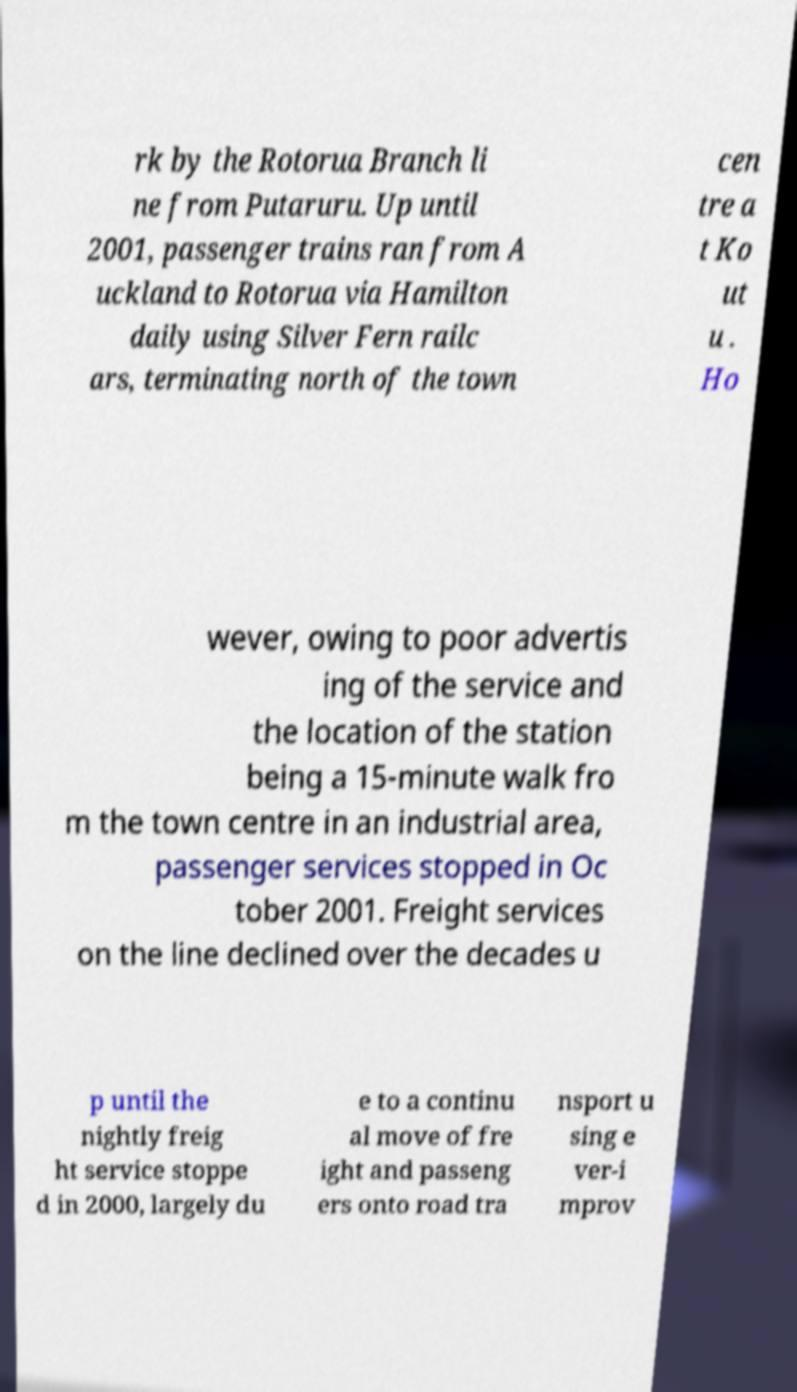For documentation purposes, I need the text within this image transcribed. Could you provide that? rk by the Rotorua Branch li ne from Putaruru. Up until 2001, passenger trains ran from A uckland to Rotorua via Hamilton daily using Silver Fern railc ars, terminating north of the town cen tre a t Ko ut u . Ho wever, owing to poor advertis ing of the service and the location of the station being a 15-minute walk fro m the town centre in an industrial area, passenger services stopped in Oc tober 2001. Freight services on the line declined over the decades u p until the nightly freig ht service stoppe d in 2000, largely du e to a continu al move of fre ight and passeng ers onto road tra nsport u sing e ver-i mprov 